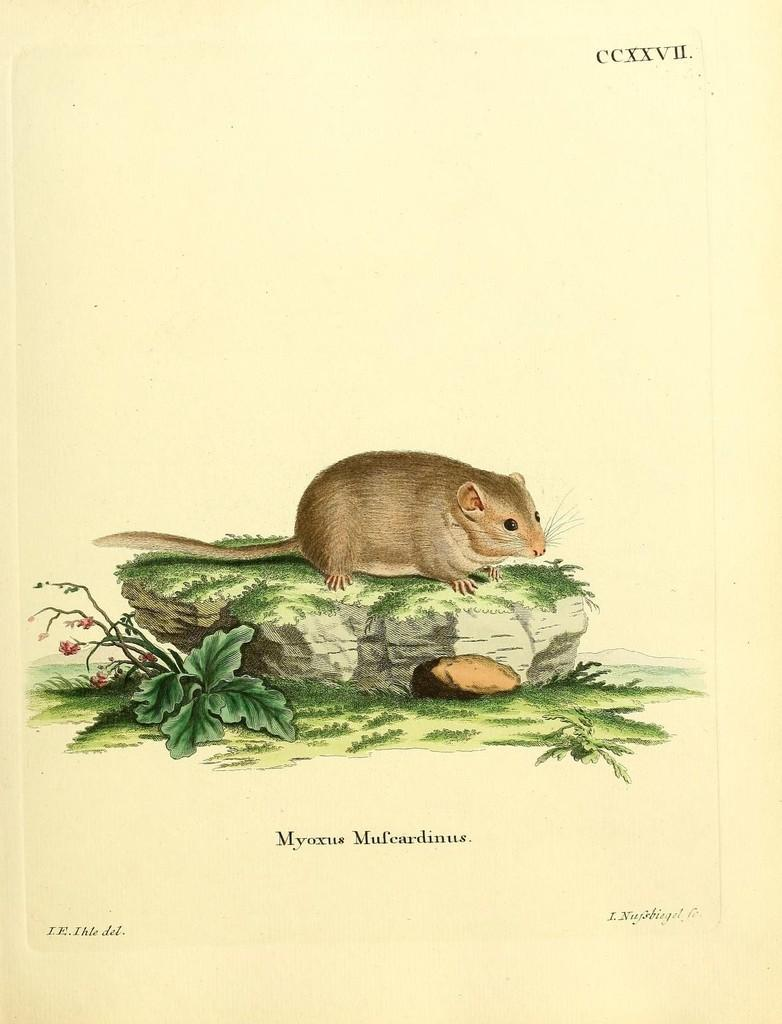What is the main subject of the image? The main subject of the image is a white paper. What is depicted on the white paper? There is a stone depicted on the paper. What is sitting on the stone? There is a brown rat on the stone. What can be seen on the left side of the image? There is a small green plant on the left side of the image. What type of agreement is being signed by the rat in the image? There is no agreement being signed in the image, nor is there any indication that the rat is capable of signing an agreement. 